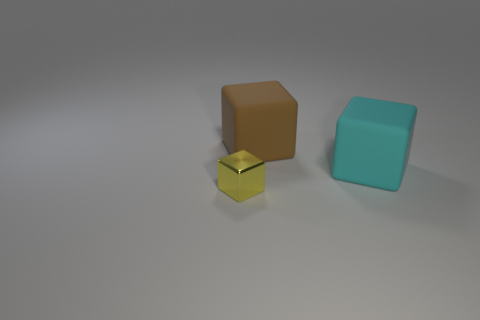Subtract all brown blocks. How many blocks are left? 2 Subtract all cyan cubes. How many cubes are left? 2 Add 1 matte objects. How many objects exist? 4 Subtract 2 blocks. How many blocks are left? 1 Subtract 0 cyan spheres. How many objects are left? 3 Subtract all red blocks. Subtract all yellow cylinders. How many blocks are left? 3 Subtract all small green shiny blocks. Subtract all tiny yellow cubes. How many objects are left? 2 Add 1 tiny yellow shiny objects. How many tiny yellow shiny objects are left? 2 Add 1 cubes. How many cubes exist? 4 